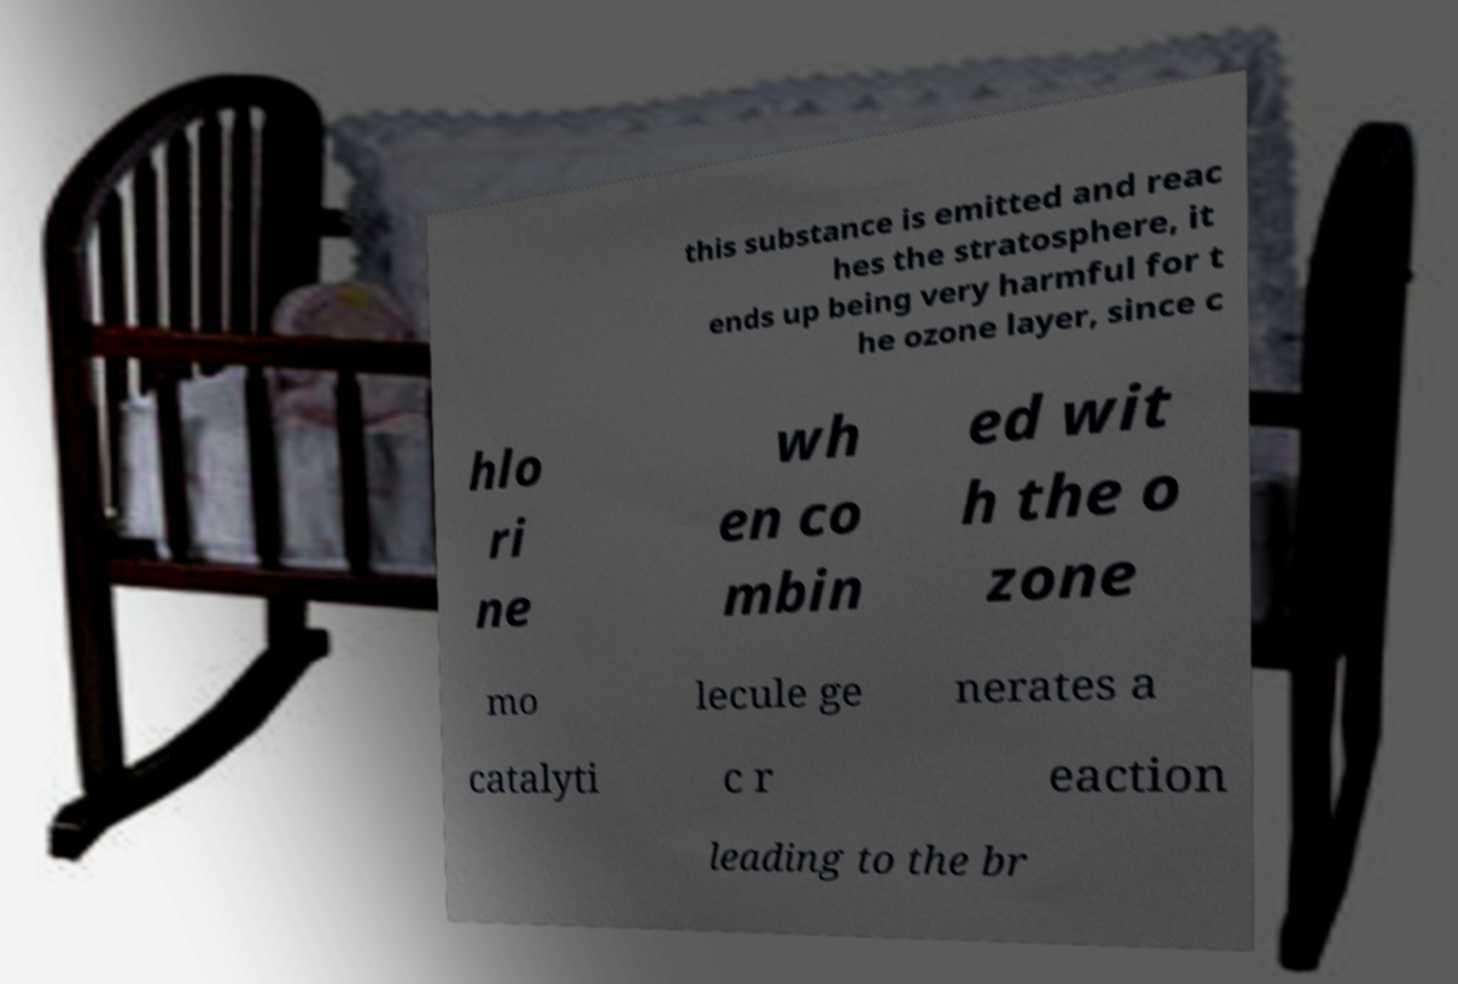Can you accurately transcribe the text from the provided image for me? this substance is emitted and reac hes the stratosphere, it ends up being very harmful for t he ozone layer, since c hlo ri ne wh en co mbin ed wit h the o zone mo lecule ge nerates a catalyti c r eaction leading to the br 